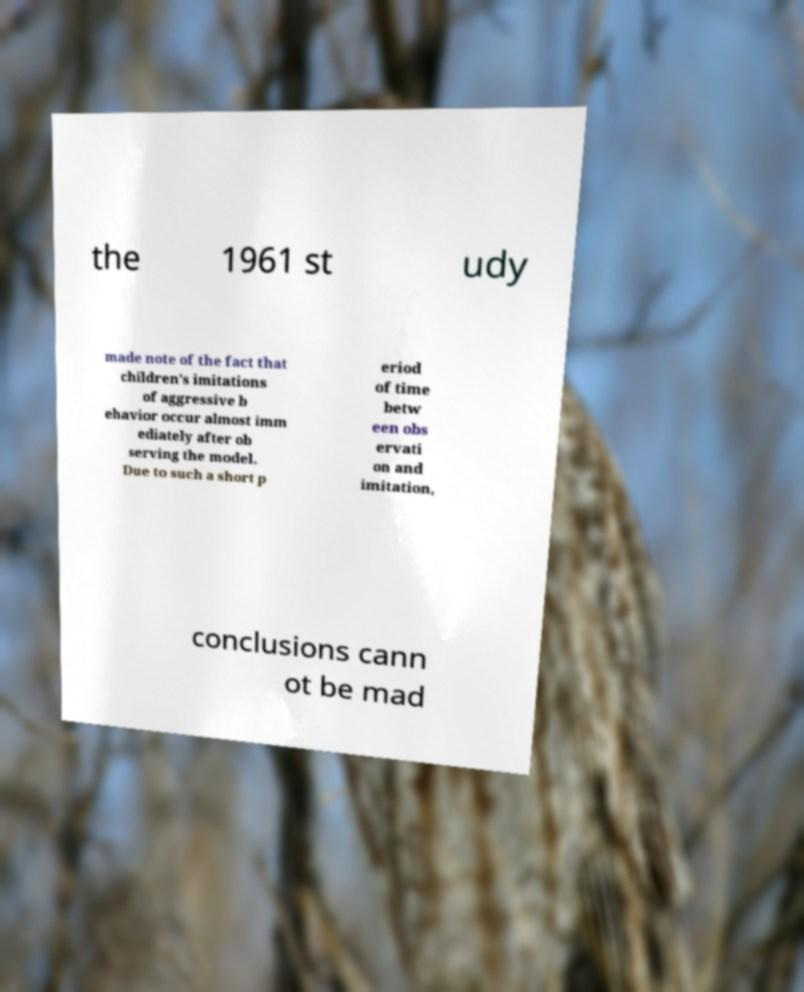Could you extract and type out the text from this image? the 1961 st udy made note of the fact that children's imitations of aggressive b ehavior occur almost imm ediately after ob serving the model. Due to such a short p eriod of time betw een obs ervati on and imitation, conclusions cann ot be mad 